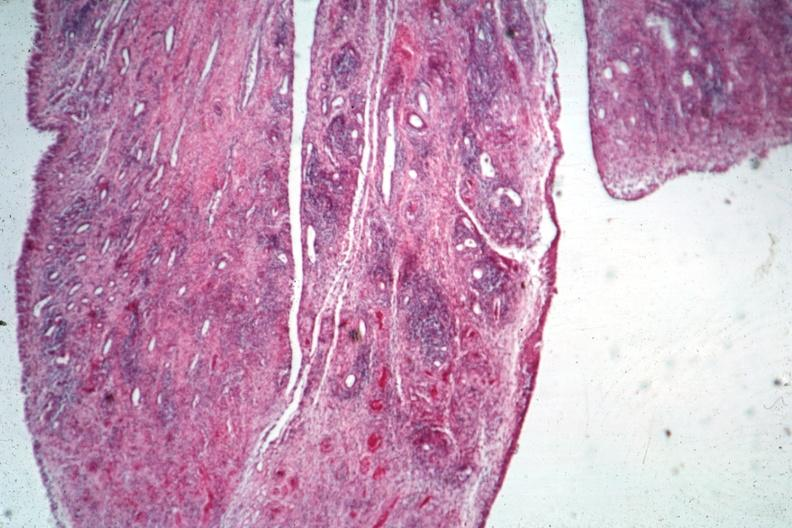s hearts present?
Answer the question using a single word or phrase. No 